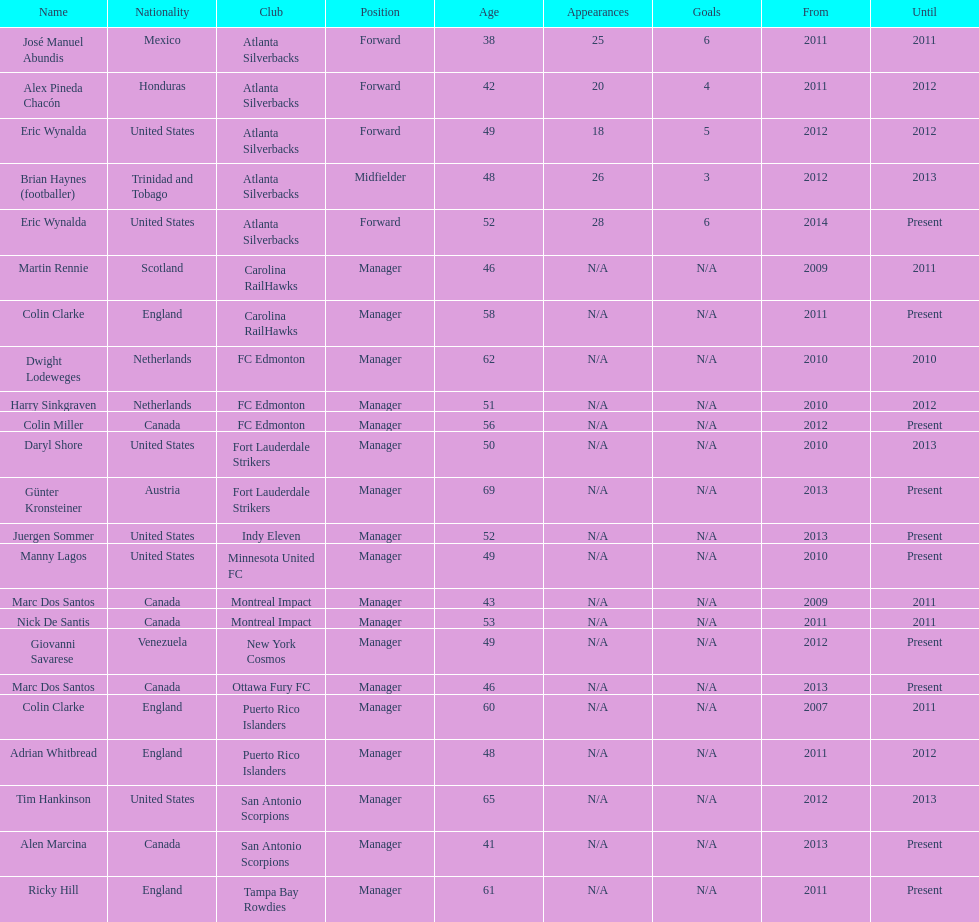Could you help me parse every detail presented in this table? {'header': ['Name', 'Nationality', 'Club', 'Position', 'Age', 'Appearances', 'Goals', 'From', 'Until'], 'rows': [['José Manuel Abundis', 'Mexico', 'Atlanta Silverbacks', 'Forward', '38', '25', '6', '2011', '2011'], ['Alex Pineda Chacón', 'Honduras', 'Atlanta Silverbacks', 'Forward', '42', '20', '4', '2011', '2012'], ['Eric Wynalda', 'United States', 'Atlanta Silverbacks', 'Forward', '49', '18', '5', '2012', '2012'], ['Brian Haynes (footballer)', 'Trinidad and Tobago', 'Atlanta Silverbacks', 'Midfielder', '48', '26', '3', '2012', '2013'], ['Eric Wynalda', 'United States', 'Atlanta Silverbacks', 'Forward', '52', '28', '6', '2014', 'Present'], ['Martin Rennie', 'Scotland', 'Carolina RailHawks', 'Manager', '46', 'N/A', 'N/A', '2009', '2011'], ['Colin Clarke', 'England', 'Carolina RailHawks', 'Manager', '58', 'N/A', 'N/A', '2011', 'Present'], ['Dwight Lodeweges', 'Netherlands', 'FC Edmonton', 'Manager', '62', 'N/A', 'N/A', '2010', '2010'], ['Harry Sinkgraven', 'Netherlands', 'FC Edmonton', 'Manager', '51', 'N/A', 'N/A', '2010', '2012'], ['Colin Miller', 'Canada', 'FC Edmonton', 'Manager', '56', 'N/A', 'N/A', '2012', 'Present'], ['Daryl Shore', 'United States', 'Fort Lauderdale Strikers', 'Manager', '50', 'N/A', 'N/A', '2010', '2013'], ['Günter Kronsteiner', 'Austria', 'Fort Lauderdale Strikers', 'Manager', '69', 'N/A', 'N/A', '2013', 'Present'], ['Juergen Sommer', 'United States', 'Indy Eleven', 'Manager', '52', 'N/A', 'N/A', '2013', 'Present'], ['Manny Lagos', 'United States', 'Minnesota United FC', 'Manager', '49', 'N/A', 'N/A', '2010', 'Present'], ['Marc Dos Santos', 'Canada', 'Montreal Impact', 'Manager', '43', 'N/A', 'N/A', '2009', '2011'], ['Nick De Santis', 'Canada', 'Montreal Impact', 'Manager', '53', 'N/A', 'N/A', '2011', '2011'], ['Giovanni Savarese', 'Venezuela', 'New York Cosmos', 'Manager', '49', 'N/A', 'N/A', '2012', 'Present'], ['Marc Dos Santos', 'Canada', 'Ottawa Fury FC', 'Manager', '46', 'N/A', 'N/A', '2013', 'Present'], ['Colin Clarke', 'England', 'Puerto Rico Islanders', 'Manager', '60', 'N/A', 'N/A', '2007', '2011'], ['Adrian Whitbread', 'England', 'Puerto Rico Islanders', 'Manager', '48', 'N/A', 'N/A', '2011', '2012'], ['Tim Hankinson', 'United States', 'San Antonio Scorpions', 'Manager', '65', 'N/A', 'N/A', '2012', '2013'], ['Alen Marcina', 'Canada', 'San Antonio Scorpions', 'Manager', '41', 'N/A', 'N/A', '2013', 'Present'], ['Ricky Hill', 'England', 'Tampa Bay Rowdies', 'Manager', '61', 'N/A', 'N/A', '2011', 'Present']]} Who coached the silverbacks longer, abundis or chacon? Chacon. 